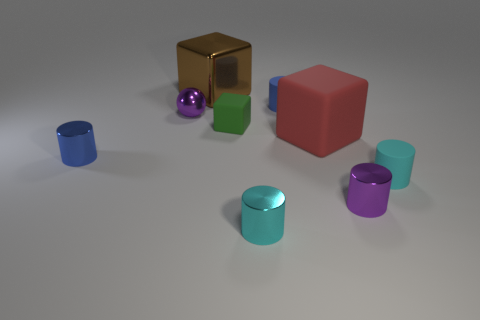There is a small blue object to the left of the purple thing to the left of the red rubber cube; what is it made of?
Provide a succinct answer. Metal. Is the size of the metal thing to the right of the blue rubber thing the same as the big brown shiny thing?
Your answer should be compact. No. Are there any matte things of the same color as the big rubber block?
Ensure brevity in your answer.  No. What number of objects are big brown metallic cubes behind the green matte block or tiny purple objects that are behind the small purple metal cylinder?
Your answer should be compact. 2. Are there fewer large objects that are in front of the small green cube than green things that are in front of the brown object?
Your answer should be compact. No. Does the brown cube have the same material as the tiny green object?
Make the answer very short. No. How big is the metal object that is to the left of the brown shiny thing and behind the green block?
Offer a very short reply. Small. There is a object that is the same size as the shiny block; what shape is it?
Your response must be concise. Cube. What material is the purple thing that is left of the cyan cylinder in front of the cyan cylinder behind the purple cylinder made of?
Make the answer very short. Metal. Do the purple metallic thing in front of the red thing and the tiny matte object that is right of the red cube have the same shape?
Your response must be concise. Yes. 